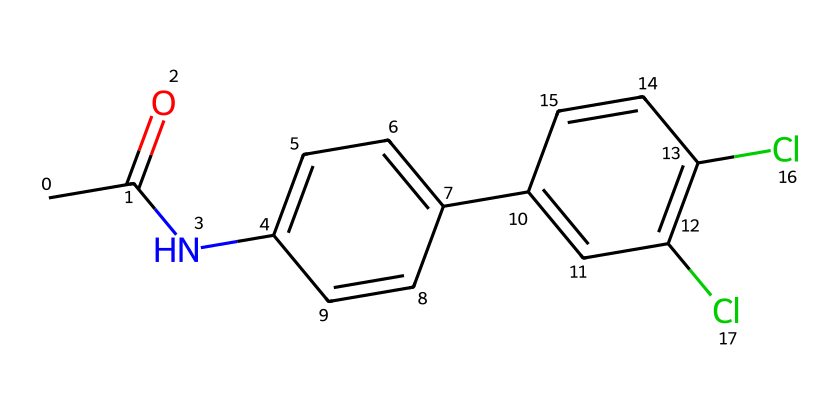What is the molecular formula of Diclofenac? To determine the molecular formula, count the number of each type of atom in the SMILES representation. There are 14 carbon atoms, 11 hydrogen atoms, 2 nitrogen atoms, and 2 chlorine atoms, which gives the formula C14H11Cl2N.
Answer: C14H11Cl2N How many rings are present in the structure? Inspect the chemical structure for any circular arrangements of atoms. The provided structure contains two fused benzene rings, which are characteristic of Diclofenac. Thus, there are two rings.
Answer: 2 What type of drug is Diclofenac categorized as? Diclofenac is primarily an anti-inflammatory medication, which can relieve pain, swelling, and fever. Given its use and chemical structure, it is categorized as a non-steroidal anti-inflammatory drug (NSAID).
Answer: NSAID Which functional group is responsible for the anti-inflammatory effects of Diclofenac? The presence of the carboxylic acid (-COOH) functional group or the amide linkage in this structure is crucial for the biological activity and anti-inflammatory properties of Diclofenac. The amide bond contributes to its stability and function.
Answer: amide How many chlorine atoms are in the structure? Look at the chemical representation for chlorine atoms, which are represented by 'Cl'. In the SMILES string, 'Cl' appears twice, indicating there are two chlorine atoms in the structure.
Answer: 2 What is the significance of the nitrogen atoms in Diclofenac? The nitrogen atoms in the structure indicate that Diclofenac contains an amine or amide group, which is important for its interaction with biological targets in the body, enhancing its anti-inflammatory mechanism and pharmacological activity.
Answer: amine/amide What is the total number of hydrogen atoms in the chemical structure? Analyze the molecular structure to identify the number of hydrogen atoms attached to the carbon skeleton. By summing the implicit hydrogens and those represented, one finds there are 11 hydrogen atoms in total.
Answer: 11 